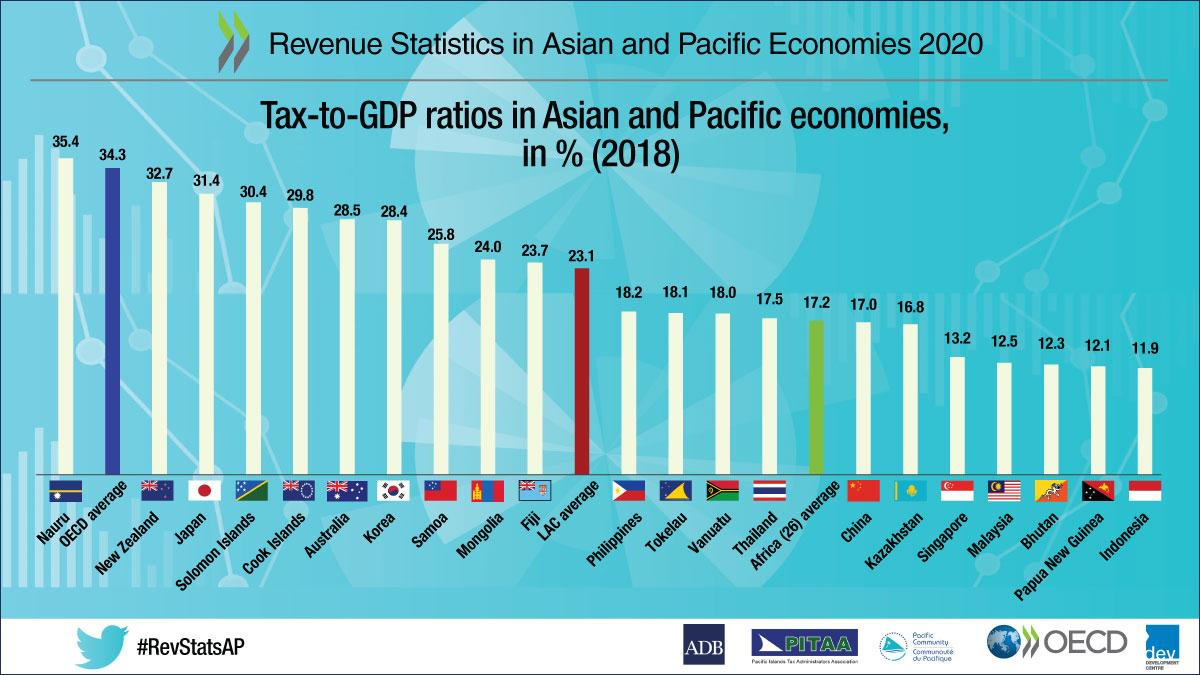Mention a couple of crucial points in this snapshot. Tokelau has a tax-to-GDP ratio of 18.1%, indicating that the country's government collected 18.1% of its Gross Domestic Product (GDP) in taxes in a given year. The red-colored bar indicates the Latin America and Caribbean (LAC) average. The tax-to-GDP ratio of the seventh economy from the left, excluding the OECD average, is 28.4%. Indonesia has the lowest tax-to-GDP ratio among all economies, demonstrating its commitment to fiscal responsibility and prudent financial management. After Nauru, New Zealand has the highest tax-to-GDP ratio. 